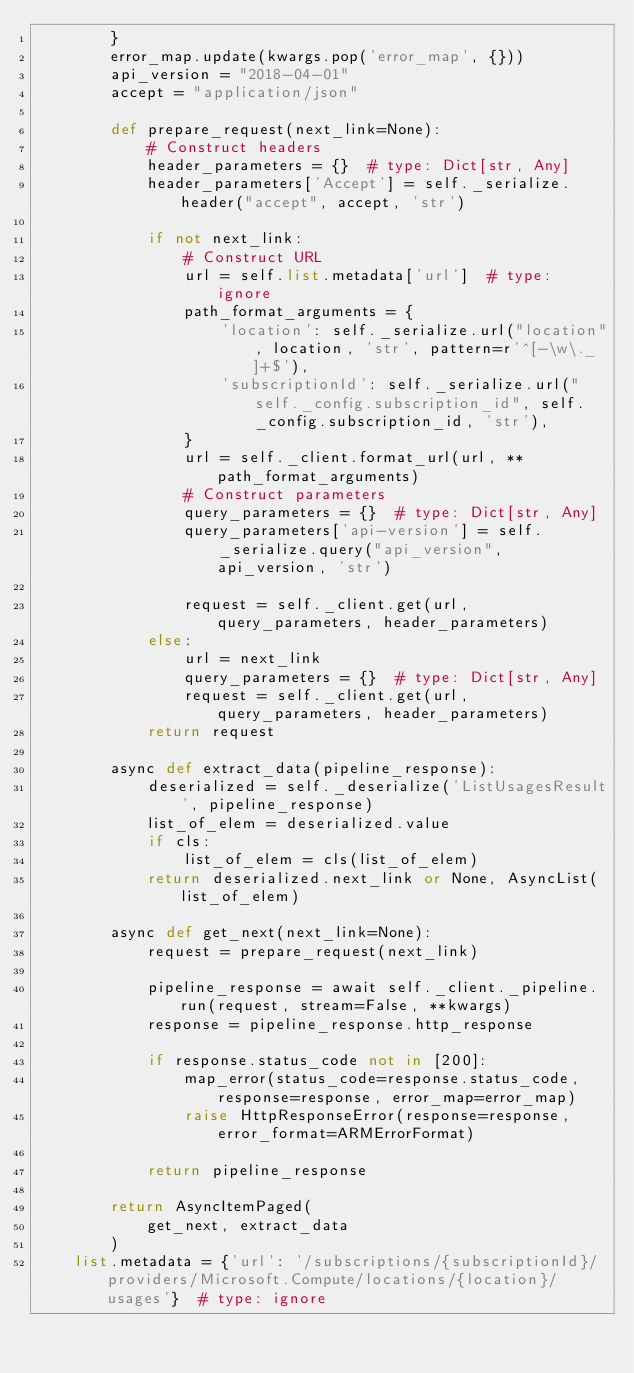Convert code to text. <code><loc_0><loc_0><loc_500><loc_500><_Python_>        }
        error_map.update(kwargs.pop('error_map', {}))
        api_version = "2018-04-01"
        accept = "application/json"

        def prepare_request(next_link=None):
            # Construct headers
            header_parameters = {}  # type: Dict[str, Any]
            header_parameters['Accept'] = self._serialize.header("accept", accept, 'str')

            if not next_link:
                # Construct URL
                url = self.list.metadata['url']  # type: ignore
                path_format_arguments = {
                    'location': self._serialize.url("location", location, 'str', pattern=r'^[-\w\._]+$'),
                    'subscriptionId': self._serialize.url("self._config.subscription_id", self._config.subscription_id, 'str'),
                }
                url = self._client.format_url(url, **path_format_arguments)
                # Construct parameters
                query_parameters = {}  # type: Dict[str, Any]
                query_parameters['api-version'] = self._serialize.query("api_version", api_version, 'str')

                request = self._client.get(url, query_parameters, header_parameters)
            else:
                url = next_link
                query_parameters = {}  # type: Dict[str, Any]
                request = self._client.get(url, query_parameters, header_parameters)
            return request

        async def extract_data(pipeline_response):
            deserialized = self._deserialize('ListUsagesResult', pipeline_response)
            list_of_elem = deserialized.value
            if cls:
                list_of_elem = cls(list_of_elem)
            return deserialized.next_link or None, AsyncList(list_of_elem)

        async def get_next(next_link=None):
            request = prepare_request(next_link)

            pipeline_response = await self._client._pipeline.run(request, stream=False, **kwargs)
            response = pipeline_response.http_response

            if response.status_code not in [200]:
                map_error(status_code=response.status_code, response=response, error_map=error_map)
                raise HttpResponseError(response=response, error_format=ARMErrorFormat)

            return pipeline_response

        return AsyncItemPaged(
            get_next, extract_data
        )
    list.metadata = {'url': '/subscriptions/{subscriptionId}/providers/Microsoft.Compute/locations/{location}/usages'}  # type: ignore
</code> 